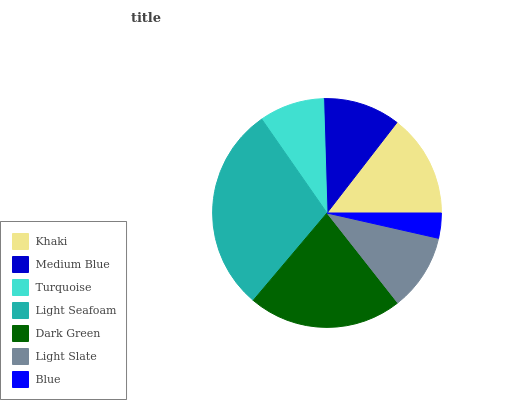Is Blue the minimum?
Answer yes or no. Yes. Is Light Seafoam the maximum?
Answer yes or no. Yes. Is Medium Blue the minimum?
Answer yes or no. No. Is Medium Blue the maximum?
Answer yes or no. No. Is Khaki greater than Medium Blue?
Answer yes or no. Yes. Is Medium Blue less than Khaki?
Answer yes or no. Yes. Is Medium Blue greater than Khaki?
Answer yes or no. No. Is Khaki less than Medium Blue?
Answer yes or no. No. Is Medium Blue the high median?
Answer yes or no. Yes. Is Medium Blue the low median?
Answer yes or no. Yes. Is Blue the high median?
Answer yes or no. No. Is Turquoise the low median?
Answer yes or no. No. 